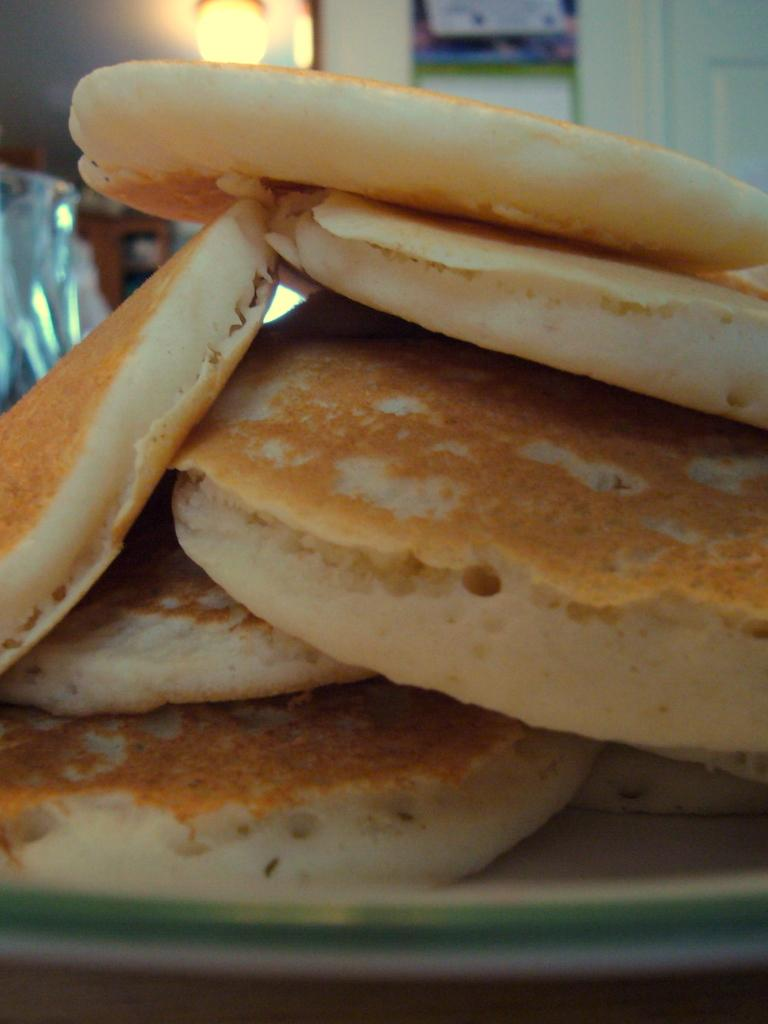What is on the plate that is visible in the image? There are food items on a plate in the image. What can be seen providing illumination in the image? There is a light visible in the image. What type of structure is present in the image? There is a wall in the image. How would you describe the background of the image? The background of the image is blurred. What direction is the island located in the image? There is no island present in the image. What is the temper of the person eating the food in the image? There is no person eating the food in the image, so it is not possible to determine their temper. 